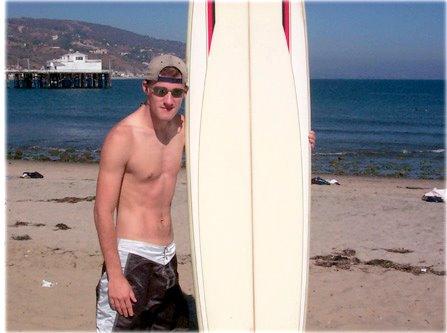What sport will the man be doing?
Quick response, please. Surfing. Are the visible waves sufficient for a surfing tournament?
Quick response, please. No. Is the surfboard bigger than the man?
Be succinct. Yes. 